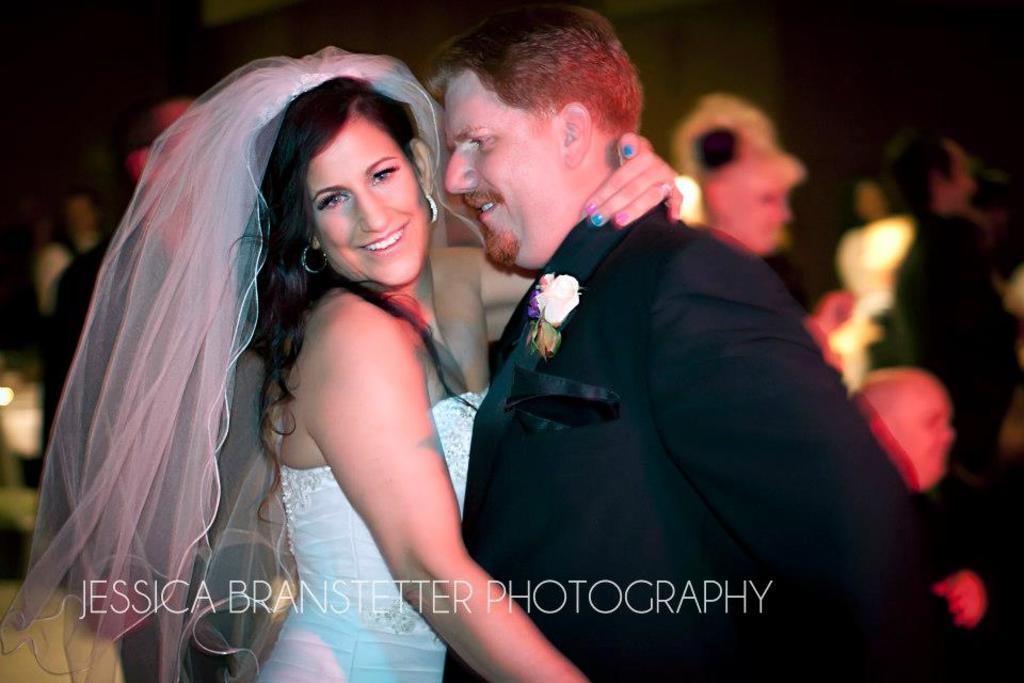Could you give a brief overview of what you see in this image? In this picture we can see a man and a woman are smiling in the front, there is some text at the bottom, we can see some people in the middle, there is a blurry background. 